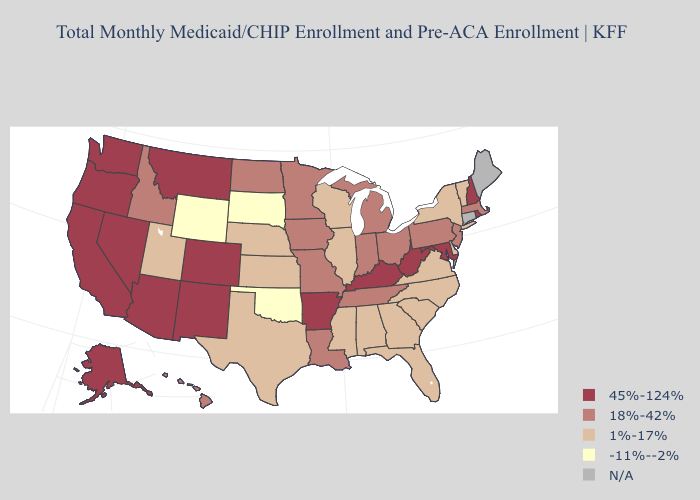Among the states that border Virginia , does North Carolina have the lowest value?
Quick response, please. Yes. Does North Carolina have the highest value in the USA?
Answer briefly. No. Which states hav the highest value in the West?
Answer briefly. Alaska, Arizona, California, Colorado, Montana, Nevada, New Mexico, Oregon, Washington. What is the lowest value in the MidWest?
Be succinct. -11%--2%. How many symbols are there in the legend?
Concise answer only. 5. Does Oklahoma have the highest value in the South?
Write a very short answer. No. Name the states that have a value in the range 18%-42%?
Quick response, please. Hawaii, Idaho, Indiana, Iowa, Louisiana, Massachusetts, Michigan, Minnesota, Missouri, New Jersey, North Dakota, Ohio, Pennsylvania, Tennessee. Does New Hampshire have the lowest value in the Northeast?
Short answer required. No. How many symbols are there in the legend?
Write a very short answer. 5. Among the states that border New Mexico , does Arizona have the highest value?
Concise answer only. Yes. What is the highest value in the South ?
Quick response, please. 45%-124%. What is the lowest value in the USA?
Give a very brief answer. -11%--2%. Name the states that have a value in the range 45%-124%?
Short answer required. Alaska, Arizona, Arkansas, California, Colorado, Kentucky, Maryland, Montana, Nevada, New Hampshire, New Mexico, Oregon, Rhode Island, Washington, West Virginia. Does the map have missing data?
Quick response, please. Yes. 